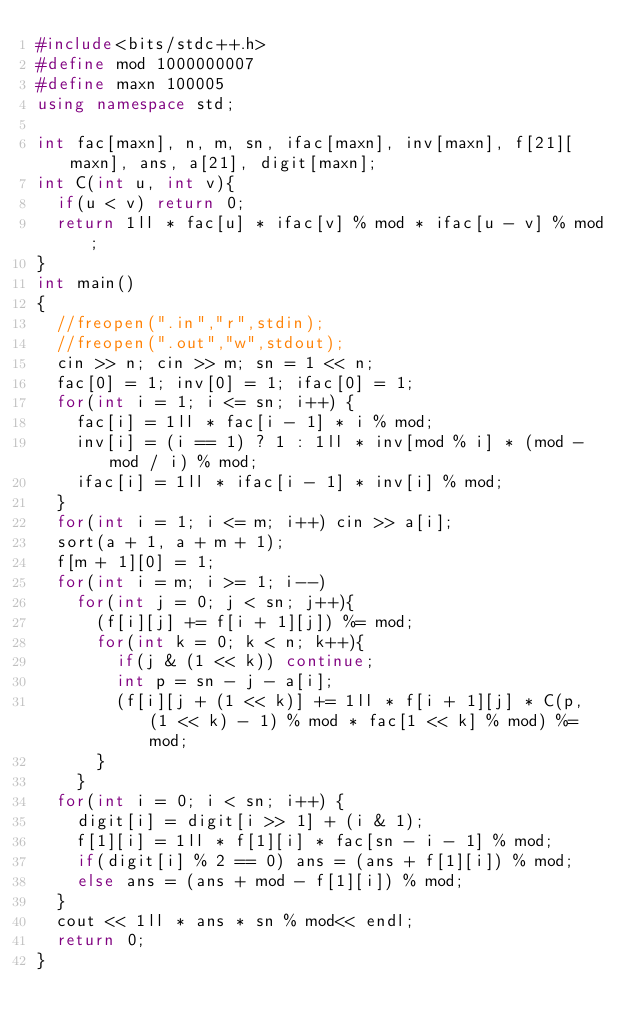<code> <loc_0><loc_0><loc_500><loc_500><_C++_>#include<bits/stdc++.h>
#define mod 1000000007
#define maxn 100005
using namespace std;

int fac[maxn], n, m, sn, ifac[maxn], inv[maxn], f[21][maxn], ans, a[21], digit[maxn];
int C(int u, int v){
	if(u < v) return 0;
	return 1ll * fac[u] * ifac[v] % mod * ifac[u - v] % mod; 
}
int main()
{
	//freopen(".in","r",stdin);
	//freopen(".out","w",stdout);
	cin >> n; cin >> m; sn = 1 << n;
	fac[0] = 1; inv[0] = 1; ifac[0] = 1;
	for(int i = 1; i <= sn; i++) {
		fac[i] = 1ll * fac[i - 1] * i % mod;
		inv[i] = (i == 1) ? 1 : 1ll * inv[mod % i] * (mod - mod / i) % mod;
		ifac[i] = 1ll * ifac[i - 1] * inv[i] % mod; 
	}
	for(int i = 1; i <= m; i++) cin >> a[i];
	sort(a + 1, a + m + 1);
	f[m + 1][0] = 1;
	for(int i = m; i >= 1; i--)
		for(int j = 0; j < sn; j++){
			(f[i][j] += f[i + 1][j]) %= mod;
			for(int k = 0; k < n; k++){
				if(j & (1 << k)) continue;
				int p = sn - j - a[i];
				(f[i][j + (1 << k)] += 1ll * f[i + 1][j] * C(p, (1 << k) - 1) % mod * fac[1 << k] % mod) %= mod;
			}
		}
	for(int i = 0; i < sn; i++) {
		digit[i] = digit[i >> 1] + (i & 1);
		f[1][i] = 1ll * f[1][i] * fac[sn - i - 1] % mod;
		if(digit[i] % 2 == 0) ans = (ans + f[1][i]) % mod;
		else ans = (ans + mod - f[1][i]) % mod;
	}
	cout << 1ll * ans * sn % mod<< endl;
	return 0;
}</code> 